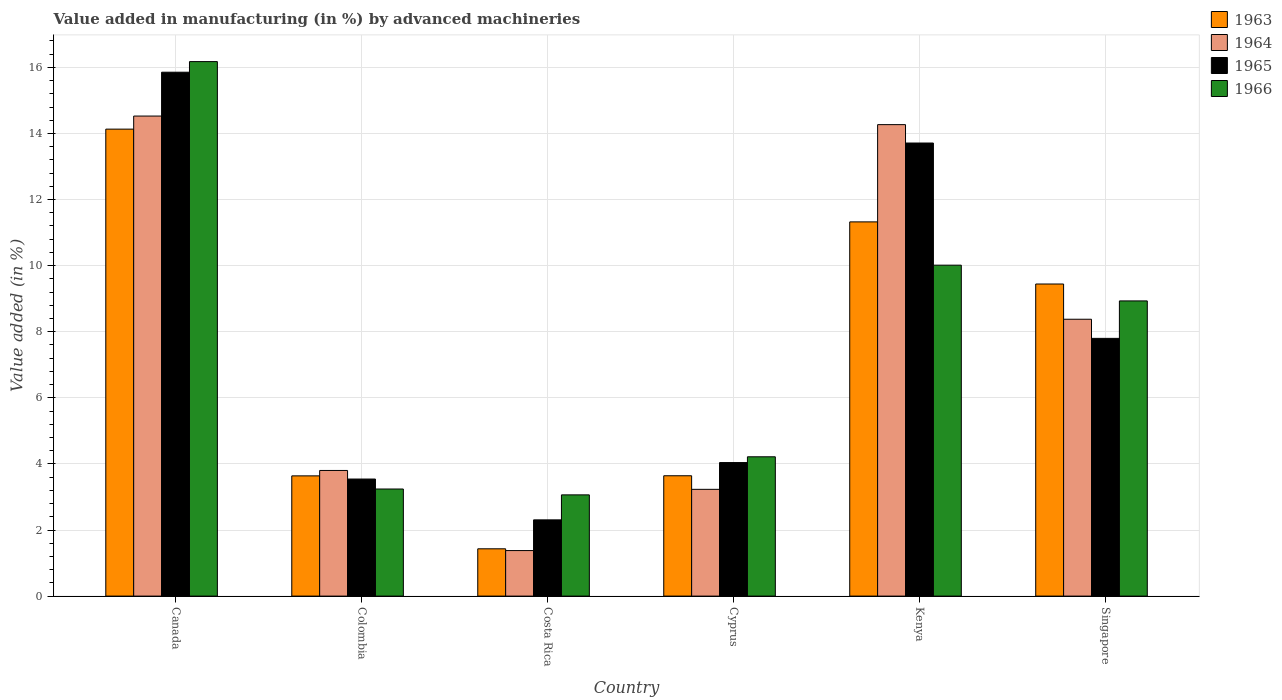How many bars are there on the 3rd tick from the right?
Ensure brevity in your answer.  4. What is the percentage of value added in manufacturing by advanced machineries in 1963 in Singapore?
Keep it short and to the point. 9.44. Across all countries, what is the maximum percentage of value added in manufacturing by advanced machineries in 1966?
Give a very brief answer. 16.17. Across all countries, what is the minimum percentage of value added in manufacturing by advanced machineries in 1966?
Your answer should be compact. 3.06. In which country was the percentage of value added in manufacturing by advanced machineries in 1963 maximum?
Keep it short and to the point. Canada. In which country was the percentage of value added in manufacturing by advanced machineries in 1963 minimum?
Provide a succinct answer. Costa Rica. What is the total percentage of value added in manufacturing by advanced machineries in 1964 in the graph?
Keep it short and to the point. 45.58. What is the difference between the percentage of value added in manufacturing by advanced machineries in 1965 in Colombia and that in Singapore?
Ensure brevity in your answer.  -4.26. What is the difference between the percentage of value added in manufacturing by advanced machineries in 1963 in Colombia and the percentage of value added in manufacturing by advanced machineries in 1966 in Costa Rica?
Make the answer very short. 0.57. What is the average percentage of value added in manufacturing by advanced machineries in 1964 per country?
Provide a short and direct response. 7.6. What is the difference between the percentage of value added in manufacturing by advanced machineries of/in 1964 and percentage of value added in manufacturing by advanced machineries of/in 1966 in Kenya?
Offer a terse response. 4.25. What is the ratio of the percentage of value added in manufacturing by advanced machineries in 1964 in Costa Rica to that in Cyprus?
Your response must be concise. 0.43. Is the difference between the percentage of value added in manufacturing by advanced machineries in 1964 in Costa Rica and Kenya greater than the difference between the percentage of value added in manufacturing by advanced machineries in 1966 in Costa Rica and Kenya?
Make the answer very short. No. What is the difference between the highest and the second highest percentage of value added in manufacturing by advanced machineries in 1966?
Make the answer very short. 7.24. What is the difference between the highest and the lowest percentage of value added in manufacturing by advanced machineries in 1966?
Your response must be concise. 13.11. In how many countries, is the percentage of value added in manufacturing by advanced machineries in 1966 greater than the average percentage of value added in manufacturing by advanced machineries in 1966 taken over all countries?
Provide a succinct answer. 3. What does the 3rd bar from the left in Kenya represents?
Your response must be concise. 1965. What does the 3rd bar from the right in Kenya represents?
Keep it short and to the point. 1964. Is it the case that in every country, the sum of the percentage of value added in manufacturing by advanced machineries in 1964 and percentage of value added in manufacturing by advanced machineries in 1965 is greater than the percentage of value added in manufacturing by advanced machineries in 1966?
Offer a very short reply. Yes. Are all the bars in the graph horizontal?
Offer a terse response. No. Does the graph contain any zero values?
Your answer should be very brief. No. Does the graph contain grids?
Your answer should be compact. Yes. Where does the legend appear in the graph?
Offer a very short reply. Top right. How are the legend labels stacked?
Ensure brevity in your answer.  Vertical. What is the title of the graph?
Give a very brief answer. Value added in manufacturing (in %) by advanced machineries. What is the label or title of the X-axis?
Keep it short and to the point. Country. What is the label or title of the Y-axis?
Provide a succinct answer. Value added (in %). What is the Value added (in %) in 1963 in Canada?
Offer a terse response. 14.13. What is the Value added (in %) of 1964 in Canada?
Ensure brevity in your answer.  14.53. What is the Value added (in %) in 1965 in Canada?
Your response must be concise. 15.85. What is the Value added (in %) in 1966 in Canada?
Give a very brief answer. 16.17. What is the Value added (in %) of 1963 in Colombia?
Provide a short and direct response. 3.64. What is the Value added (in %) in 1964 in Colombia?
Provide a succinct answer. 3.8. What is the Value added (in %) in 1965 in Colombia?
Your response must be concise. 3.54. What is the Value added (in %) of 1966 in Colombia?
Offer a terse response. 3.24. What is the Value added (in %) in 1963 in Costa Rica?
Keep it short and to the point. 1.43. What is the Value added (in %) in 1964 in Costa Rica?
Offer a terse response. 1.38. What is the Value added (in %) in 1965 in Costa Rica?
Your response must be concise. 2.31. What is the Value added (in %) of 1966 in Costa Rica?
Provide a succinct answer. 3.06. What is the Value added (in %) of 1963 in Cyprus?
Offer a terse response. 3.64. What is the Value added (in %) in 1964 in Cyprus?
Offer a very short reply. 3.23. What is the Value added (in %) in 1965 in Cyprus?
Give a very brief answer. 4.04. What is the Value added (in %) in 1966 in Cyprus?
Make the answer very short. 4.22. What is the Value added (in %) in 1963 in Kenya?
Make the answer very short. 11.32. What is the Value added (in %) in 1964 in Kenya?
Ensure brevity in your answer.  14.27. What is the Value added (in %) of 1965 in Kenya?
Provide a short and direct response. 13.71. What is the Value added (in %) in 1966 in Kenya?
Provide a short and direct response. 10.01. What is the Value added (in %) in 1963 in Singapore?
Offer a very short reply. 9.44. What is the Value added (in %) of 1964 in Singapore?
Make the answer very short. 8.38. What is the Value added (in %) of 1965 in Singapore?
Keep it short and to the point. 7.8. What is the Value added (in %) of 1966 in Singapore?
Make the answer very short. 8.93. Across all countries, what is the maximum Value added (in %) in 1963?
Make the answer very short. 14.13. Across all countries, what is the maximum Value added (in %) in 1964?
Ensure brevity in your answer.  14.53. Across all countries, what is the maximum Value added (in %) in 1965?
Your response must be concise. 15.85. Across all countries, what is the maximum Value added (in %) in 1966?
Your answer should be compact. 16.17. Across all countries, what is the minimum Value added (in %) in 1963?
Give a very brief answer. 1.43. Across all countries, what is the minimum Value added (in %) of 1964?
Your answer should be compact. 1.38. Across all countries, what is the minimum Value added (in %) in 1965?
Offer a terse response. 2.31. Across all countries, what is the minimum Value added (in %) in 1966?
Provide a succinct answer. 3.06. What is the total Value added (in %) in 1963 in the graph?
Your answer should be very brief. 43.61. What is the total Value added (in %) of 1964 in the graph?
Give a very brief answer. 45.58. What is the total Value added (in %) in 1965 in the graph?
Ensure brevity in your answer.  47.25. What is the total Value added (in %) of 1966 in the graph?
Provide a short and direct response. 45.64. What is the difference between the Value added (in %) of 1963 in Canada and that in Colombia?
Offer a very short reply. 10.49. What is the difference between the Value added (in %) in 1964 in Canada and that in Colombia?
Offer a very short reply. 10.72. What is the difference between the Value added (in %) of 1965 in Canada and that in Colombia?
Offer a very short reply. 12.31. What is the difference between the Value added (in %) in 1966 in Canada and that in Colombia?
Your answer should be very brief. 12.93. What is the difference between the Value added (in %) in 1963 in Canada and that in Costa Rica?
Your answer should be very brief. 12.7. What is the difference between the Value added (in %) of 1964 in Canada and that in Costa Rica?
Give a very brief answer. 13.15. What is the difference between the Value added (in %) in 1965 in Canada and that in Costa Rica?
Keep it short and to the point. 13.55. What is the difference between the Value added (in %) of 1966 in Canada and that in Costa Rica?
Make the answer very short. 13.11. What is the difference between the Value added (in %) in 1963 in Canada and that in Cyprus?
Ensure brevity in your answer.  10.49. What is the difference between the Value added (in %) in 1964 in Canada and that in Cyprus?
Provide a succinct answer. 11.3. What is the difference between the Value added (in %) in 1965 in Canada and that in Cyprus?
Give a very brief answer. 11.81. What is the difference between the Value added (in %) in 1966 in Canada and that in Cyprus?
Give a very brief answer. 11.96. What is the difference between the Value added (in %) in 1963 in Canada and that in Kenya?
Your answer should be very brief. 2.81. What is the difference between the Value added (in %) of 1964 in Canada and that in Kenya?
Your response must be concise. 0.26. What is the difference between the Value added (in %) in 1965 in Canada and that in Kenya?
Provide a succinct answer. 2.14. What is the difference between the Value added (in %) of 1966 in Canada and that in Kenya?
Ensure brevity in your answer.  6.16. What is the difference between the Value added (in %) of 1963 in Canada and that in Singapore?
Your answer should be very brief. 4.69. What is the difference between the Value added (in %) in 1964 in Canada and that in Singapore?
Offer a very short reply. 6.15. What is the difference between the Value added (in %) in 1965 in Canada and that in Singapore?
Provide a short and direct response. 8.05. What is the difference between the Value added (in %) in 1966 in Canada and that in Singapore?
Your answer should be very brief. 7.24. What is the difference between the Value added (in %) of 1963 in Colombia and that in Costa Rica?
Your response must be concise. 2.21. What is the difference between the Value added (in %) of 1964 in Colombia and that in Costa Rica?
Provide a short and direct response. 2.42. What is the difference between the Value added (in %) in 1965 in Colombia and that in Costa Rica?
Your answer should be compact. 1.24. What is the difference between the Value added (in %) in 1966 in Colombia and that in Costa Rica?
Your answer should be compact. 0.18. What is the difference between the Value added (in %) in 1963 in Colombia and that in Cyprus?
Offer a very short reply. -0. What is the difference between the Value added (in %) in 1964 in Colombia and that in Cyprus?
Provide a succinct answer. 0.57. What is the difference between the Value added (in %) of 1965 in Colombia and that in Cyprus?
Provide a short and direct response. -0.5. What is the difference between the Value added (in %) of 1966 in Colombia and that in Cyprus?
Give a very brief answer. -0.97. What is the difference between the Value added (in %) in 1963 in Colombia and that in Kenya?
Your response must be concise. -7.69. What is the difference between the Value added (in %) in 1964 in Colombia and that in Kenya?
Provide a short and direct response. -10.47. What is the difference between the Value added (in %) of 1965 in Colombia and that in Kenya?
Provide a succinct answer. -10.17. What is the difference between the Value added (in %) in 1966 in Colombia and that in Kenya?
Ensure brevity in your answer.  -6.77. What is the difference between the Value added (in %) of 1963 in Colombia and that in Singapore?
Your answer should be very brief. -5.81. What is the difference between the Value added (in %) of 1964 in Colombia and that in Singapore?
Provide a succinct answer. -4.58. What is the difference between the Value added (in %) of 1965 in Colombia and that in Singapore?
Make the answer very short. -4.26. What is the difference between the Value added (in %) of 1966 in Colombia and that in Singapore?
Give a very brief answer. -5.69. What is the difference between the Value added (in %) in 1963 in Costa Rica and that in Cyprus?
Your answer should be compact. -2.21. What is the difference between the Value added (in %) of 1964 in Costa Rica and that in Cyprus?
Provide a succinct answer. -1.85. What is the difference between the Value added (in %) in 1965 in Costa Rica and that in Cyprus?
Provide a short and direct response. -1.73. What is the difference between the Value added (in %) of 1966 in Costa Rica and that in Cyprus?
Offer a very short reply. -1.15. What is the difference between the Value added (in %) of 1963 in Costa Rica and that in Kenya?
Offer a very short reply. -9.89. What is the difference between the Value added (in %) in 1964 in Costa Rica and that in Kenya?
Provide a succinct answer. -12.89. What is the difference between the Value added (in %) of 1965 in Costa Rica and that in Kenya?
Your response must be concise. -11.4. What is the difference between the Value added (in %) in 1966 in Costa Rica and that in Kenya?
Provide a succinct answer. -6.95. What is the difference between the Value added (in %) of 1963 in Costa Rica and that in Singapore?
Give a very brief answer. -8.01. What is the difference between the Value added (in %) in 1964 in Costa Rica and that in Singapore?
Provide a short and direct response. -7. What is the difference between the Value added (in %) in 1965 in Costa Rica and that in Singapore?
Your answer should be very brief. -5.49. What is the difference between the Value added (in %) of 1966 in Costa Rica and that in Singapore?
Ensure brevity in your answer.  -5.87. What is the difference between the Value added (in %) of 1963 in Cyprus and that in Kenya?
Your response must be concise. -7.68. What is the difference between the Value added (in %) of 1964 in Cyprus and that in Kenya?
Ensure brevity in your answer.  -11.04. What is the difference between the Value added (in %) in 1965 in Cyprus and that in Kenya?
Your answer should be very brief. -9.67. What is the difference between the Value added (in %) of 1966 in Cyprus and that in Kenya?
Your answer should be compact. -5.8. What is the difference between the Value added (in %) of 1963 in Cyprus and that in Singapore?
Your response must be concise. -5.8. What is the difference between the Value added (in %) in 1964 in Cyprus and that in Singapore?
Your answer should be very brief. -5.15. What is the difference between the Value added (in %) in 1965 in Cyprus and that in Singapore?
Offer a very short reply. -3.76. What is the difference between the Value added (in %) of 1966 in Cyprus and that in Singapore?
Give a very brief answer. -4.72. What is the difference between the Value added (in %) in 1963 in Kenya and that in Singapore?
Provide a succinct answer. 1.88. What is the difference between the Value added (in %) in 1964 in Kenya and that in Singapore?
Give a very brief answer. 5.89. What is the difference between the Value added (in %) in 1965 in Kenya and that in Singapore?
Your answer should be very brief. 5.91. What is the difference between the Value added (in %) in 1966 in Kenya and that in Singapore?
Offer a very short reply. 1.08. What is the difference between the Value added (in %) of 1963 in Canada and the Value added (in %) of 1964 in Colombia?
Ensure brevity in your answer.  10.33. What is the difference between the Value added (in %) of 1963 in Canada and the Value added (in %) of 1965 in Colombia?
Make the answer very short. 10.59. What is the difference between the Value added (in %) of 1963 in Canada and the Value added (in %) of 1966 in Colombia?
Ensure brevity in your answer.  10.89. What is the difference between the Value added (in %) in 1964 in Canada and the Value added (in %) in 1965 in Colombia?
Your answer should be very brief. 10.98. What is the difference between the Value added (in %) in 1964 in Canada and the Value added (in %) in 1966 in Colombia?
Keep it short and to the point. 11.29. What is the difference between the Value added (in %) of 1965 in Canada and the Value added (in %) of 1966 in Colombia?
Your answer should be very brief. 12.61. What is the difference between the Value added (in %) of 1963 in Canada and the Value added (in %) of 1964 in Costa Rica?
Your answer should be very brief. 12.75. What is the difference between the Value added (in %) of 1963 in Canada and the Value added (in %) of 1965 in Costa Rica?
Provide a succinct answer. 11.82. What is the difference between the Value added (in %) of 1963 in Canada and the Value added (in %) of 1966 in Costa Rica?
Provide a short and direct response. 11.07. What is the difference between the Value added (in %) in 1964 in Canada and the Value added (in %) in 1965 in Costa Rica?
Keep it short and to the point. 12.22. What is the difference between the Value added (in %) in 1964 in Canada and the Value added (in %) in 1966 in Costa Rica?
Offer a very short reply. 11.46. What is the difference between the Value added (in %) of 1965 in Canada and the Value added (in %) of 1966 in Costa Rica?
Give a very brief answer. 12.79. What is the difference between the Value added (in %) of 1963 in Canada and the Value added (in %) of 1964 in Cyprus?
Provide a short and direct response. 10.9. What is the difference between the Value added (in %) of 1963 in Canada and the Value added (in %) of 1965 in Cyprus?
Your answer should be very brief. 10.09. What is the difference between the Value added (in %) in 1963 in Canada and the Value added (in %) in 1966 in Cyprus?
Keep it short and to the point. 9.92. What is the difference between the Value added (in %) of 1964 in Canada and the Value added (in %) of 1965 in Cyprus?
Your response must be concise. 10.49. What is the difference between the Value added (in %) of 1964 in Canada and the Value added (in %) of 1966 in Cyprus?
Offer a terse response. 10.31. What is the difference between the Value added (in %) in 1965 in Canada and the Value added (in %) in 1966 in Cyprus?
Give a very brief answer. 11.64. What is the difference between the Value added (in %) of 1963 in Canada and the Value added (in %) of 1964 in Kenya?
Your answer should be very brief. -0.14. What is the difference between the Value added (in %) in 1963 in Canada and the Value added (in %) in 1965 in Kenya?
Your answer should be compact. 0.42. What is the difference between the Value added (in %) in 1963 in Canada and the Value added (in %) in 1966 in Kenya?
Offer a very short reply. 4.12. What is the difference between the Value added (in %) in 1964 in Canada and the Value added (in %) in 1965 in Kenya?
Your response must be concise. 0.82. What is the difference between the Value added (in %) of 1964 in Canada and the Value added (in %) of 1966 in Kenya?
Ensure brevity in your answer.  4.51. What is the difference between the Value added (in %) of 1965 in Canada and the Value added (in %) of 1966 in Kenya?
Offer a terse response. 5.84. What is the difference between the Value added (in %) in 1963 in Canada and the Value added (in %) in 1964 in Singapore?
Your answer should be compact. 5.75. What is the difference between the Value added (in %) of 1963 in Canada and the Value added (in %) of 1965 in Singapore?
Provide a short and direct response. 6.33. What is the difference between the Value added (in %) in 1963 in Canada and the Value added (in %) in 1966 in Singapore?
Make the answer very short. 5.2. What is the difference between the Value added (in %) of 1964 in Canada and the Value added (in %) of 1965 in Singapore?
Your answer should be very brief. 6.73. What is the difference between the Value added (in %) in 1964 in Canada and the Value added (in %) in 1966 in Singapore?
Make the answer very short. 5.59. What is the difference between the Value added (in %) in 1965 in Canada and the Value added (in %) in 1966 in Singapore?
Offer a terse response. 6.92. What is the difference between the Value added (in %) in 1963 in Colombia and the Value added (in %) in 1964 in Costa Rica?
Provide a short and direct response. 2.26. What is the difference between the Value added (in %) in 1963 in Colombia and the Value added (in %) in 1965 in Costa Rica?
Your response must be concise. 1.33. What is the difference between the Value added (in %) of 1963 in Colombia and the Value added (in %) of 1966 in Costa Rica?
Keep it short and to the point. 0.57. What is the difference between the Value added (in %) of 1964 in Colombia and the Value added (in %) of 1965 in Costa Rica?
Your answer should be very brief. 1.49. What is the difference between the Value added (in %) of 1964 in Colombia and the Value added (in %) of 1966 in Costa Rica?
Your answer should be very brief. 0.74. What is the difference between the Value added (in %) of 1965 in Colombia and the Value added (in %) of 1966 in Costa Rica?
Offer a very short reply. 0.48. What is the difference between the Value added (in %) of 1963 in Colombia and the Value added (in %) of 1964 in Cyprus?
Offer a terse response. 0.41. What is the difference between the Value added (in %) of 1963 in Colombia and the Value added (in %) of 1965 in Cyprus?
Give a very brief answer. -0.4. What is the difference between the Value added (in %) in 1963 in Colombia and the Value added (in %) in 1966 in Cyprus?
Give a very brief answer. -0.58. What is the difference between the Value added (in %) in 1964 in Colombia and the Value added (in %) in 1965 in Cyprus?
Make the answer very short. -0.24. What is the difference between the Value added (in %) in 1964 in Colombia and the Value added (in %) in 1966 in Cyprus?
Provide a short and direct response. -0.41. What is the difference between the Value added (in %) in 1965 in Colombia and the Value added (in %) in 1966 in Cyprus?
Offer a very short reply. -0.67. What is the difference between the Value added (in %) of 1963 in Colombia and the Value added (in %) of 1964 in Kenya?
Ensure brevity in your answer.  -10.63. What is the difference between the Value added (in %) in 1963 in Colombia and the Value added (in %) in 1965 in Kenya?
Your answer should be very brief. -10.07. What is the difference between the Value added (in %) in 1963 in Colombia and the Value added (in %) in 1966 in Kenya?
Your response must be concise. -6.38. What is the difference between the Value added (in %) in 1964 in Colombia and the Value added (in %) in 1965 in Kenya?
Give a very brief answer. -9.91. What is the difference between the Value added (in %) of 1964 in Colombia and the Value added (in %) of 1966 in Kenya?
Provide a succinct answer. -6.21. What is the difference between the Value added (in %) in 1965 in Colombia and the Value added (in %) in 1966 in Kenya?
Your response must be concise. -6.47. What is the difference between the Value added (in %) of 1963 in Colombia and the Value added (in %) of 1964 in Singapore?
Offer a very short reply. -4.74. What is the difference between the Value added (in %) in 1963 in Colombia and the Value added (in %) in 1965 in Singapore?
Offer a terse response. -4.16. What is the difference between the Value added (in %) of 1963 in Colombia and the Value added (in %) of 1966 in Singapore?
Your answer should be very brief. -5.29. What is the difference between the Value added (in %) in 1964 in Colombia and the Value added (in %) in 1965 in Singapore?
Your answer should be very brief. -4. What is the difference between the Value added (in %) in 1964 in Colombia and the Value added (in %) in 1966 in Singapore?
Offer a very short reply. -5.13. What is the difference between the Value added (in %) of 1965 in Colombia and the Value added (in %) of 1966 in Singapore?
Your answer should be very brief. -5.39. What is the difference between the Value added (in %) in 1963 in Costa Rica and the Value added (in %) in 1964 in Cyprus?
Offer a terse response. -1.8. What is the difference between the Value added (in %) in 1963 in Costa Rica and the Value added (in %) in 1965 in Cyprus?
Ensure brevity in your answer.  -2.61. What is the difference between the Value added (in %) of 1963 in Costa Rica and the Value added (in %) of 1966 in Cyprus?
Ensure brevity in your answer.  -2.78. What is the difference between the Value added (in %) in 1964 in Costa Rica and the Value added (in %) in 1965 in Cyprus?
Your response must be concise. -2.66. What is the difference between the Value added (in %) of 1964 in Costa Rica and the Value added (in %) of 1966 in Cyprus?
Give a very brief answer. -2.84. What is the difference between the Value added (in %) in 1965 in Costa Rica and the Value added (in %) in 1966 in Cyprus?
Give a very brief answer. -1.91. What is the difference between the Value added (in %) in 1963 in Costa Rica and the Value added (in %) in 1964 in Kenya?
Offer a terse response. -12.84. What is the difference between the Value added (in %) of 1963 in Costa Rica and the Value added (in %) of 1965 in Kenya?
Your response must be concise. -12.28. What is the difference between the Value added (in %) in 1963 in Costa Rica and the Value added (in %) in 1966 in Kenya?
Provide a succinct answer. -8.58. What is the difference between the Value added (in %) of 1964 in Costa Rica and the Value added (in %) of 1965 in Kenya?
Keep it short and to the point. -12.33. What is the difference between the Value added (in %) in 1964 in Costa Rica and the Value added (in %) in 1966 in Kenya?
Your answer should be compact. -8.64. What is the difference between the Value added (in %) in 1965 in Costa Rica and the Value added (in %) in 1966 in Kenya?
Provide a succinct answer. -7.71. What is the difference between the Value added (in %) in 1963 in Costa Rica and the Value added (in %) in 1964 in Singapore?
Make the answer very short. -6.95. What is the difference between the Value added (in %) of 1963 in Costa Rica and the Value added (in %) of 1965 in Singapore?
Provide a short and direct response. -6.37. What is the difference between the Value added (in %) in 1963 in Costa Rica and the Value added (in %) in 1966 in Singapore?
Offer a very short reply. -7.5. What is the difference between the Value added (in %) in 1964 in Costa Rica and the Value added (in %) in 1965 in Singapore?
Your response must be concise. -6.42. What is the difference between the Value added (in %) of 1964 in Costa Rica and the Value added (in %) of 1966 in Singapore?
Provide a succinct answer. -7.55. What is the difference between the Value added (in %) in 1965 in Costa Rica and the Value added (in %) in 1966 in Singapore?
Make the answer very short. -6.63. What is the difference between the Value added (in %) in 1963 in Cyprus and the Value added (in %) in 1964 in Kenya?
Provide a short and direct response. -10.63. What is the difference between the Value added (in %) of 1963 in Cyprus and the Value added (in %) of 1965 in Kenya?
Give a very brief answer. -10.07. What is the difference between the Value added (in %) of 1963 in Cyprus and the Value added (in %) of 1966 in Kenya?
Ensure brevity in your answer.  -6.37. What is the difference between the Value added (in %) in 1964 in Cyprus and the Value added (in %) in 1965 in Kenya?
Give a very brief answer. -10.48. What is the difference between the Value added (in %) in 1964 in Cyprus and the Value added (in %) in 1966 in Kenya?
Keep it short and to the point. -6.78. What is the difference between the Value added (in %) of 1965 in Cyprus and the Value added (in %) of 1966 in Kenya?
Provide a short and direct response. -5.97. What is the difference between the Value added (in %) of 1963 in Cyprus and the Value added (in %) of 1964 in Singapore?
Your answer should be very brief. -4.74. What is the difference between the Value added (in %) in 1963 in Cyprus and the Value added (in %) in 1965 in Singapore?
Offer a terse response. -4.16. What is the difference between the Value added (in %) of 1963 in Cyprus and the Value added (in %) of 1966 in Singapore?
Your answer should be compact. -5.29. What is the difference between the Value added (in %) of 1964 in Cyprus and the Value added (in %) of 1965 in Singapore?
Give a very brief answer. -4.57. What is the difference between the Value added (in %) of 1964 in Cyprus and the Value added (in %) of 1966 in Singapore?
Your response must be concise. -5.7. What is the difference between the Value added (in %) in 1965 in Cyprus and the Value added (in %) in 1966 in Singapore?
Give a very brief answer. -4.89. What is the difference between the Value added (in %) of 1963 in Kenya and the Value added (in %) of 1964 in Singapore?
Offer a very short reply. 2.95. What is the difference between the Value added (in %) in 1963 in Kenya and the Value added (in %) in 1965 in Singapore?
Provide a succinct answer. 3.52. What is the difference between the Value added (in %) of 1963 in Kenya and the Value added (in %) of 1966 in Singapore?
Your answer should be very brief. 2.39. What is the difference between the Value added (in %) of 1964 in Kenya and the Value added (in %) of 1965 in Singapore?
Ensure brevity in your answer.  6.47. What is the difference between the Value added (in %) of 1964 in Kenya and the Value added (in %) of 1966 in Singapore?
Keep it short and to the point. 5.33. What is the difference between the Value added (in %) of 1965 in Kenya and the Value added (in %) of 1966 in Singapore?
Give a very brief answer. 4.78. What is the average Value added (in %) of 1963 per country?
Your answer should be compact. 7.27. What is the average Value added (in %) of 1964 per country?
Offer a terse response. 7.6. What is the average Value added (in %) of 1965 per country?
Offer a very short reply. 7.88. What is the average Value added (in %) of 1966 per country?
Give a very brief answer. 7.61. What is the difference between the Value added (in %) of 1963 and Value added (in %) of 1964 in Canada?
Give a very brief answer. -0.4. What is the difference between the Value added (in %) of 1963 and Value added (in %) of 1965 in Canada?
Offer a terse response. -1.72. What is the difference between the Value added (in %) in 1963 and Value added (in %) in 1966 in Canada?
Make the answer very short. -2.04. What is the difference between the Value added (in %) in 1964 and Value added (in %) in 1965 in Canada?
Your response must be concise. -1.33. What is the difference between the Value added (in %) of 1964 and Value added (in %) of 1966 in Canada?
Offer a terse response. -1.65. What is the difference between the Value added (in %) of 1965 and Value added (in %) of 1966 in Canada?
Your answer should be very brief. -0.32. What is the difference between the Value added (in %) in 1963 and Value added (in %) in 1964 in Colombia?
Your response must be concise. -0.16. What is the difference between the Value added (in %) of 1963 and Value added (in %) of 1965 in Colombia?
Offer a terse response. 0.1. What is the difference between the Value added (in %) in 1963 and Value added (in %) in 1966 in Colombia?
Offer a very short reply. 0.4. What is the difference between the Value added (in %) in 1964 and Value added (in %) in 1965 in Colombia?
Give a very brief answer. 0.26. What is the difference between the Value added (in %) in 1964 and Value added (in %) in 1966 in Colombia?
Make the answer very short. 0.56. What is the difference between the Value added (in %) of 1965 and Value added (in %) of 1966 in Colombia?
Your response must be concise. 0.3. What is the difference between the Value added (in %) in 1963 and Value added (in %) in 1964 in Costa Rica?
Give a very brief answer. 0.05. What is the difference between the Value added (in %) of 1963 and Value added (in %) of 1965 in Costa Rica?
Give a very brief answer. -0.88. What is the difference between the Value added (in %) in 1963 and Value added (in %) in 1966 in Costa Rica?
Keep it short and to the point. -1.63. What is the difference between the Value added (in %) in 1964 and Value added (in %) in 1965 in Costa Rica?
Provide a succinct answer. -0.93. What is the difference between the Value added (in %) of 1964 and Value added (in %) of 1966 in Costa Rica?
Your answer should be very brief. -1.69. What is the difference between the Value added (in %) of 1965 and Value added (in %) of 1966 in Costa Rica?
Keep it short and to the point. -0.76. What is the difference between the Value added (in %) of 1963 and Value added (in %) of 1964 in Cyprus?
Provide a succinct answer. 0.41. What is the difference between the Value added (in %) of 1963 and Value added (in %) of 1965 in Cyprus?
Your answer should be very brief. -0.4. What is the difference between the Value added (in %) in 1963 and Value added (in %) in 1966 in Cyprus?
Offer a very short reply. -0.57. What is the difference between the Value added (in %) of 1964 and Value added (in %) of 1965 in Cyprus?
Provide a short and direct response. -0.81. What is the difference between the Value added (in %) of 1964 and Value added (in %) of 1966 in Cyprus?
Ensure brevity in your answer.  -0.98. What is the difference between the Value added (in %) in 1965 and Value added (in %) in 1966 in Cyprus?
Your response must be concise. -0.17. What is the difference between the Value added (in %) in 1963 and Value added (in %) in 1964 in Kenya?
Offer a terse response. -2.94. What is the difference between the Value added (in %) of 1963 and Value added (in %) of 1965 in Kenya?
Your answer should be compact. -2.39. What is the difference between the Value added (in %) in 1963 and Value added (in %) in 1966 in Kenya?
Offer a terse response. 1.31. What is the difference between the Value added (in %) of 1964 and Value added (in %) of 1965 in Kenya?
Your answer should be very brief. 0.56. What is the difference between the Value added (in %) of 1964 and Value added (in %) of 1966 in Kenya?
Keep it short and to the point. 4.25. What is the difference between the Value added (in %) in 1965 and Value added (in %) in 1966 in Kenya?
Your answer should be very brief. 3.7. What is the difference between the Value added (in %) in 1963 and Value added (in %) in 1964 in Singapore?
Your response must be concise. 1.07. What is the difference between the Value added (in %) of 1963 and Value added (in %) of 1965 in Singapore?
Your response must be concise. 1.64. What is the difference between the Value added (in %) in 1963 and Value added (in %) in 1966 in Singapore?
Your answer should be compact. 0.51. What is the difference between the Value added (in %) in 1964 and Value added (in %) in 1965 in Singapore?
Provide a succinct answer. 0.58. What is the difference between the Value added (in %) in 1964 and Value added (in %) in 1966 in Singapore?
Your answer should be very brief. -0.55. What is the difference between the Value added (in %) in 1965 and Value added (in %) in 1966 in Singapore?
Your answer should be very brief. -1.13. What is the ratio of the Value added (in %) of 1963 in Canada to that in Colombia?
Ensure brevity in your answer.  3.88. What is the ratio of the Value added (in %) of 1964 in Canada to that in Colombia?
Offer a terse response. 3.82. What is the ratio of the Value added (in %) in 1965 in Canada to that in Colombia?
Your answer should be compact. 4.48. What is the ratio of the Value added (in %) of 1966 in Canada to that in Colombia?
Give a very brief answer. 4.99. What is the ratio of the Value added (in %) in 1963 in Canada to that in Costa Rica?
Make the answer very short. 9.87. What is the ratio of the Value added (in %) in 1964 in Canada to that in Costa Rica?
Give a very brief answer. 10.54. What is the ratio of the Value added (in %) in 1965 in Canada to that in Costa Rica?
Provide a short and direct response. 6.87. What is the ratio of the Value added (in %) of 1966 in Canada to that in Costa Rica?
Offer a very short reply. 5.28. What is the ratio of the Value added (in %) of 1963 in Canada to that in Cyprus?
Offer a terse response. 3.88. What is the ratio of the Value added (in %) in 1964 in Canada to that in Cyprus?
Keep it short and to the point. 4.5. What is the ratio of the Value added (in %) in 1965 in Canada to that in Cyprus?
Ensure brevity in your answer.  3.92. What is the ratio of the Value added (in %) of 1966 in Canada to that in Cyprus?
Provide a succinct answer. 3.84. What is the ratio of the Value added (in %) in 1963 in Canada to that in Kenya?
Your answer should be compact. 1.25. What is the ratio of the Value added (in %) in 1964 in Canada to that in Kenya?
Offer a terse response. 1.02. What is the ratio of the Value added (in %) of 1965 in Canada to that in Kenya?
Ensure brevity in your answer.  1.16. What is the ratio of the Value added (in %) in 1966 in Canada to that in Kenya?
Offer a terse response. 1.62. What is the ratio of the Value added (in %) in 1963 in Canada to that in Singapore?
Your answer should be compact. 1.5. What is the ratio of the Value added (in %) in 1964 in Canada to that in Singapore?
Offer a terse response. 1.73. What is the ratio of the Value added (in %) in 1965 in Canada to that in Singapore?
Offer a very short reply. 2.03. What is the ratio of the Value added (in %) in 1966 in Canada to that in Singapore?
Keep it short and to the point. 1.81. What is the ratio of the Value added (in %) of 1963 in Colombia to that in Costa Rica?
Make the answer very short. 2.54. What is the ratio of the Value added (in %) of 1964 in Colombia to that in Costa Rica?
Your response must be concise. 2.76. What is the ratio of the Value added (in %) of 1965 in Colombia to that in Costa Rica?
Provide a succinct answer. 1.54. What is the ratio of the Value added (in %) of 1966 in Colombia to that in Costa Rica?
Your answer should be very brief. 1.06. What is the ratio of the Value added (in %) of 1963 in Colombia to that in Cyprus?
Provide a short and direct response. 1. What is the ratio of the Value added (in %) of 1964 in Colombia to that in Cyprus?
Your answer should be very brief. 1.18. What is the ratio of the Value added (in %) of 1965 in Colombia to that in Cyprus?
Your response must be concise. 0.88. What is the ratio of the Value added (in %) in 1966 in Colombia to that in Cyprus?
Your answer should be very brief. 0.77. What is the ratio of the Value added (in %) in 1963 in Colombia to that in Kenya?
Keep it short and to the point. 0.32. What is the ratio of the Value added (in %) in 1964 in Colombia to that in Kenya?
Keep it short and to the point. 0.27. What is the ratio of the Value added (in %) of 1965 in Colombia to that in Kenya?
Your response must be concise. 0.26. What is the ratio of the Value added (in %) in 1966 in Colombia to that in Kenya?
Your response must be concise. 0.32. What is the ratio of the Value added (in %) of 1963 in Colombia to that in Singapore?
Keep it short and to the point. 0.39. What is the ratio of the Value added (in %) of 1964 in Colombia to that in Singapore?
Your answer should be compact. 0.45. What is the ratio of the Value added (in %) of 1965 in Colombia to that in Singapore?
Keep it short and to the point. 0.45. What is the ratio of the Value added (in %) in 1966 in Colombia to that in Singapore?
Your response must be concise. 0.36. What is the ratio of the Value added (in %) of 1963 in Costa Rica to that in Cyprus?
Provide a succinct answer. 0.39. What is the ratio of the Value added (in %) in 1964 in Costa Rica to that in Cyprus?
Your answer should be compact. 0.43. What is the ratio of the Value added (in %) of 1965 in Costa Rica to that in Cyprus?
Provide a short and direct response. 0.57. What is the ratio of the Value added (in %) of 1966 in Costa Rica to that in Cyprus?
Offer a terse response. 0.73. What is the ratio of the Value added (in %) of 1963 in Costa Rica to that in Kenya?
Offer a very short reply. 0.13. What is the ratio of the Value added (in %) of 1964 in Costa Rica to that in Kenya?
Offer a very short reply. 0.1. What is the ratio of the Value added (in %) in 1965 in Costa Rica to that in Kenya?
Provide a succinct answer. 0.17. What is the ratio of the Value added (in %) of 1966 in Costa Rica to that in Kenya?
Give a very brief answer. 0.31. What is the ratio of the Value added (in %) in 1963 in Costa Rica to that in Singapore?
Offer a terse response. 0.15. What is the ratio of the Value added (in %) in 1964 in Costa Rica to that in Singapore?
Offer a terse response. 0.16. What is the ratio of the Value added (in %) of 1965 in Costa Rica to that in Singapore?
Make the answer very short. 0.3. What is the ratio of the Value added (in %) in 1966 in Costa Rica to that in Singapore?
Your answer should be compact. 0.34. What is the ratio of the Value added (in %) of 1963 in Cyprus to that in Kenya?
Your answer should be very brief. 0.32. What is the ratio of the Value added (in %) of 1964 in Cyprus to that in Kenya?
Offer a terse response. 0.23. What is the ratio of the Value added (in %) in 1965 in Cyprus to that in Kenya?
Keep it short and to the point. 0.29. What is the ratio of the Value added (in %) of 1966 in Cyprus to that in Kenya?
Provide a succinct answer. 0.42. What is the ratio of the Value added (in %) of 1963 in Cyprus to that in Singapore?
Make the answer very short. 0.39. What is the ratio of the Value added (in %) of 1964 in Cyprus to that in Singapore?
Keep it short and to the point. 0.39. What is the ratio of the Value added (in %) of 1965 in Cyprus to that in Singapore?
Keep it short and to the point. 0.52. What is the ratio of the Value added (in %) in 1966 in Cyprus to that in Singapore?
Offer a terse response. 0.47. What is the ratio of the Value added (in %) of 1963 in Kenya to that in Singapore?
Provide a succinct answer. 1.2. What is the ratio of the Value added (in %) of 1964 in Kenya to that in Singapore?
Ensure brevity in your answer.  1.7. What is the ratio of the Value added (in %) of 1965 in Kenya to that in Singapore?
Make the answer very short. 1.76. What is the ratio of the Value added (in %) in 1966 in Kenya to that in Singapore?
Your answer should be very brief. 1.12. What is the difference between the highest and the second highest Value added (in %) in 1963?
Offer a terse response. 2.81. What is the difference between the highest and the second highest Value added (in %) of 1964?
Give a very brief answer. 0.26. What is the difference between the highest and the second highest Value added (in %) in 1965?
Make the answer very short. 2.14. What is the difference between the highest and the second highest Value added (in %) in 1966?
Your answer should be compact. 6.16. What is the difference between the highest and the lowest Value added (in %) in 1963?
Keep it short and to the point. 12.7. What is the difference between the highest and the lowest Value added (in %) in 1964?
Your response must be concise. 13.15. What is the difference between the highest and the lowest Value added (in %) of 1965?
Give a very brief answer. 13.55. What is the difference between the highest and the lowest Value added (in %) in 1966?
Make the answer very short. 13.11. 